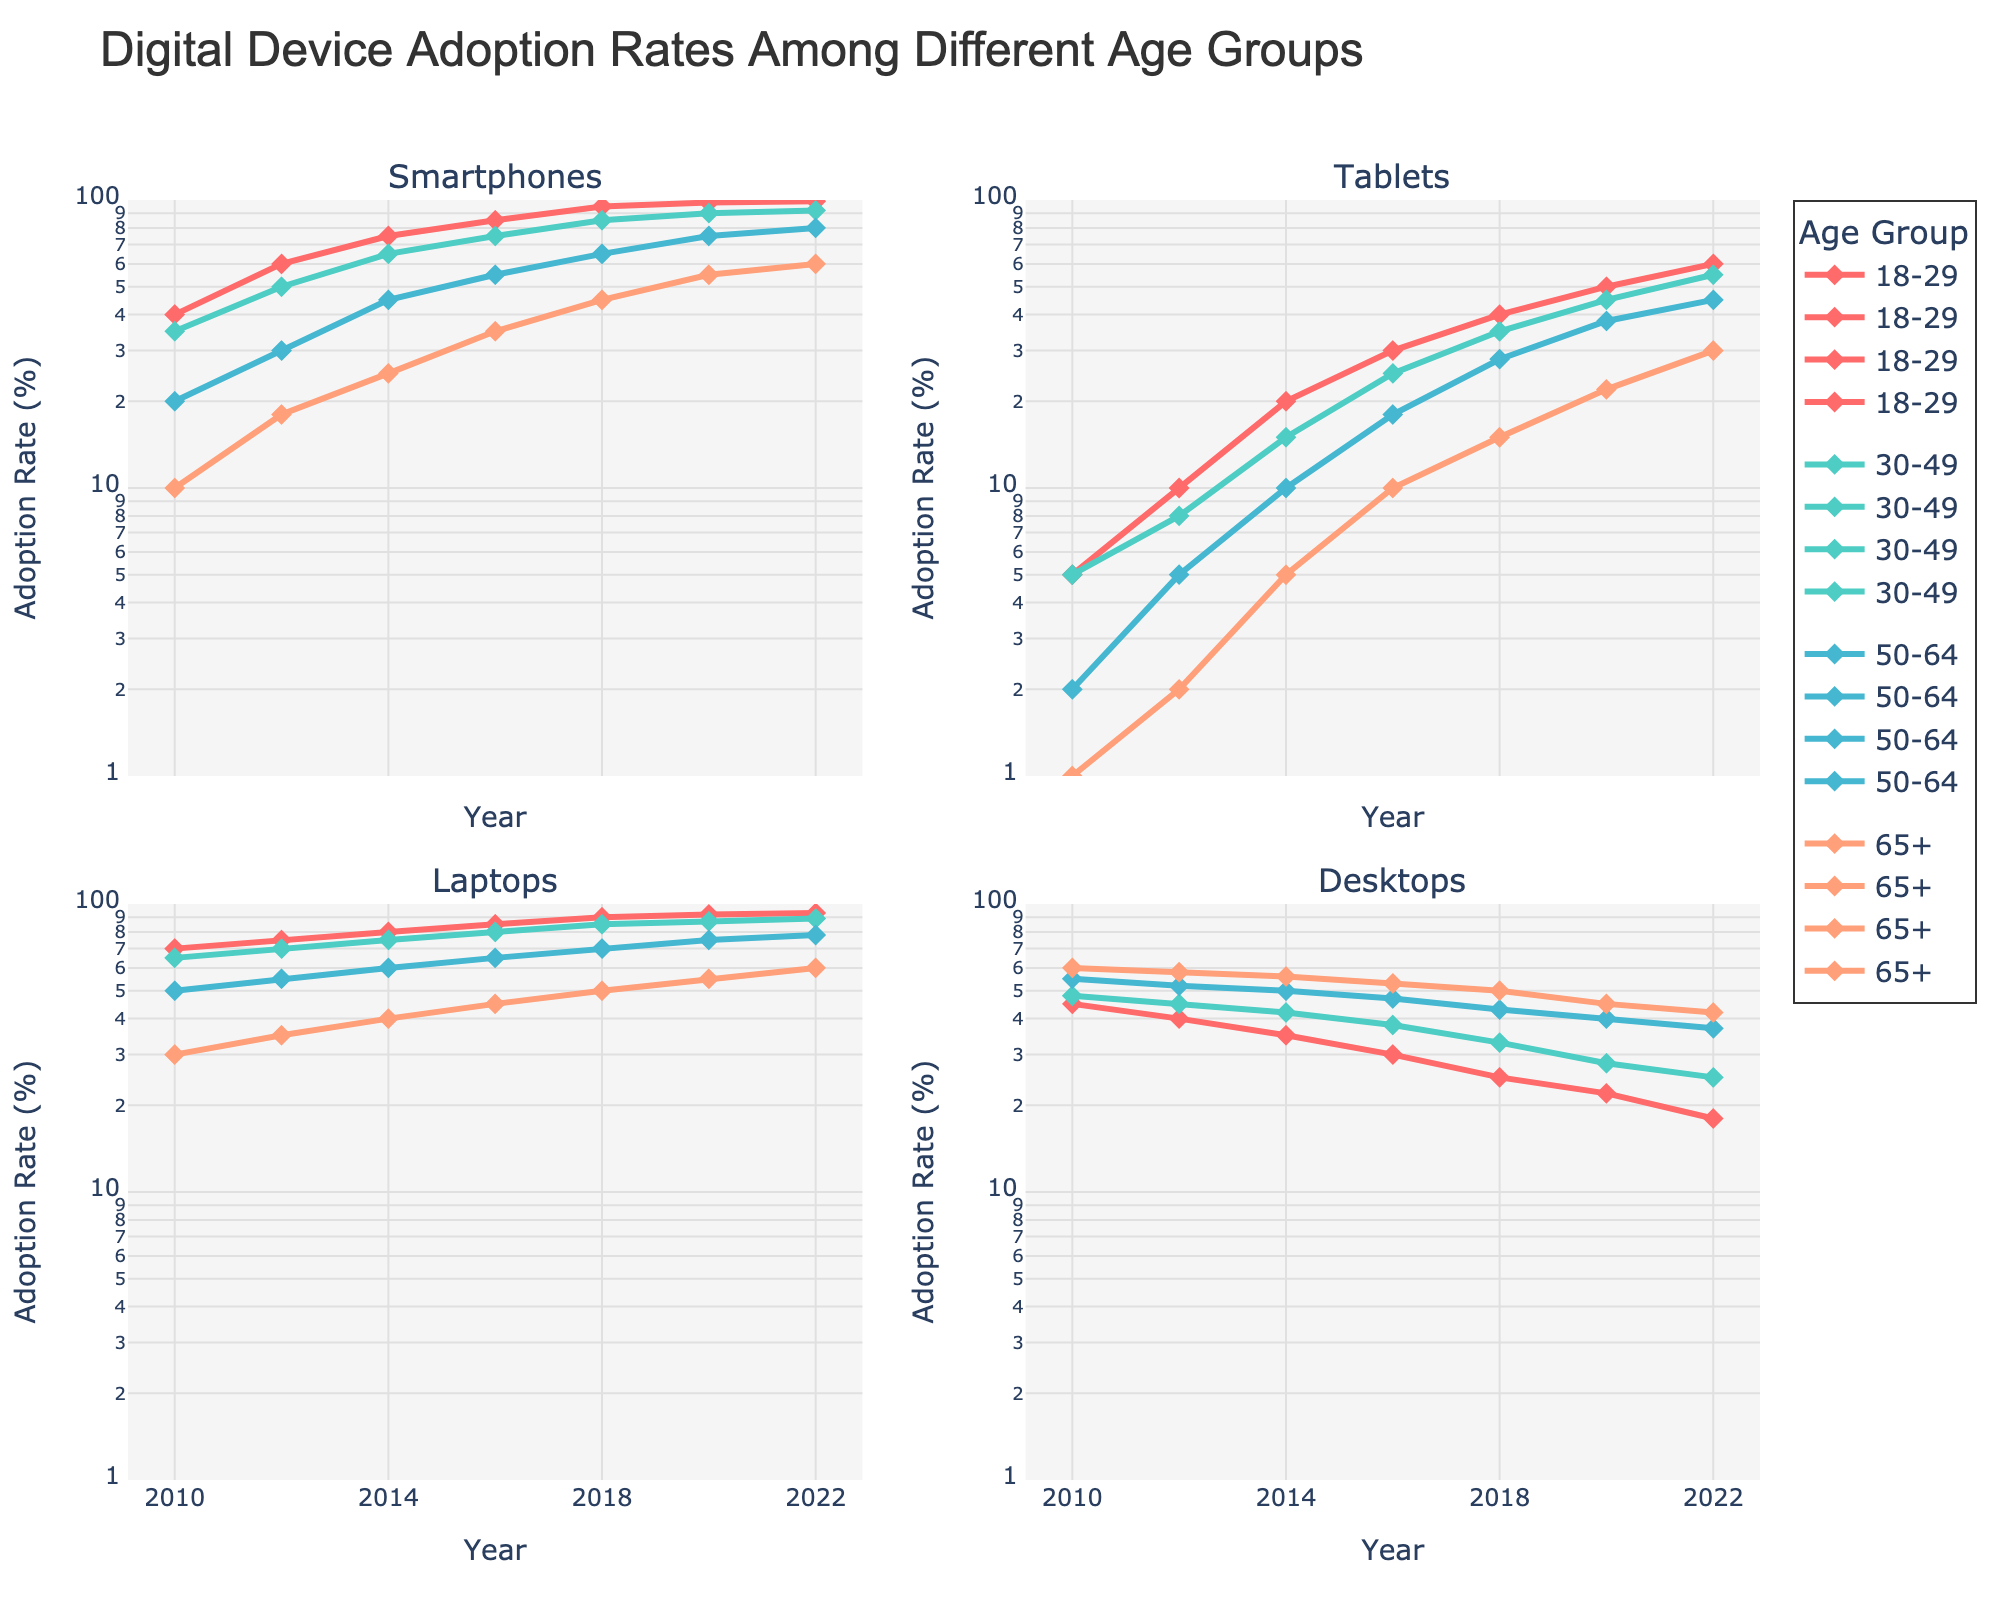Which age group had the highest adoption rate for smartphones in 2022? To find this, look at the "Smartphones" subplot in 2022 and compare all age groups. The highest y-axis value corresponds to the 18-29 age group.
Answer: 18-29 What's the approximate adoption rate for tablets among the 30-49 age group in 2014? Locate the "Tablets" subplot, find the 30-49 age group, and match it to the year 2014. The adoption rate is just under 10%.
Answer: 15% Which age group showed the most significant increase in laptop adoption from 2010 to 2022? Compare the laptop adoption rates in 2010 and 2022 across age groups to see which had the largest difference. The 18-29 age group had the smallest increase.
Answer: 18-29 By what factor did smartphone adoption increase for the 50-64 age group between 2010 and 2022? In the "Smartphones" subplot, compare the rates for the 50-64 age group in 2010 (20%) and 2022 (80%). The factor of increase is 80/20 = 4.
Answer: 4 What is the trend for desktop adoption in the 65+ age group over the years? Check the "Desktops" subplot and note the trend for the 65+ age group. The plot shows a decreasing trend.
Answer: Decreasing How many data points are presented in the "Tablets" subplot for the 18-29 age group? Count the markers shown for the 18-29 age group in the "Tablets" subplot from 2010 to 2022. There are seven points.
Answer: 7 Which device had a nearly constant adoption rate for any age group? Look for plots where the lines are relatively flat. The "Desktops" subplot for the 18-29 age group shows a steady decline.
Answer: Desktops Between which years did the 30-49 age group see the highest increase in tablet adoption? Focus on the "Tablets" subplot for the 30-49 age group and identify the steepest increase between two consecutive years, which is between 2014 to 2016.
Answer: 2014-2016 What was the approximate adoption rate of laptops for the 65+ age group in 2018? In the "Laptops" subplot, locate the 65+ age group and find the rate around 2018. The adoption rate is about 50%.
Answer: 50% Is there any device that shows a decline in adoption rate for the 18-29 age group from 2010 to 2022? The "Desktops" subplot for the 18-29 age group shows a decreasing trend. Verify this by observing the downward line from 2010 to 2022.
Answer: Yes, Desktops 